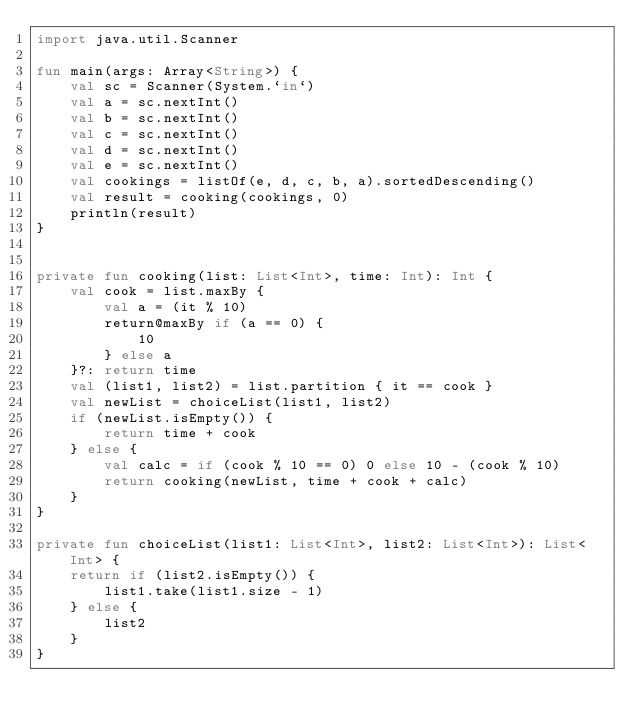Convert code to text. <code><loc_0><loc_0><loc_500><loc_500><_Kotlin_>import java.util.Scanner

fun main(args: Array<String>) {
    val sc = Scanner(System.`in`)
    val a = sc.nextInt()
    val b = sc.nextInt()
    val c = sc.nextInt()
    val d = sc.nextInt()
    val e = sc.nextInt()
    val cookings = listOf(e, d, c, b, a).sortedDescending()
    val result = cooking(cookings, 0)
    println(result)
}


private fun cooking(list: List<Int>, time: Int): Int {
    val cook = list.maxBy {
        val a = (it % 10)
        return@maxBy if (a == 0) {
            10
        } else a
    }?: return time
    val (list1, list2) = list.partition { it == cook }
    val newList = choiceList(list1, list2)
    if (newList.isEmpty()) {
        return time + cook
    } else {
        val calc = if (cook % 10 == 0) 0 else 10 - (cook % 10)
        return cooking(newList, time + cook + calc)
    }
}

private fun choiceList(list1: List<Int>, list2: List<Int>): List<Int> {
    return if (list2.isEmpty()) {
        list1.take(list1.size - 1)
    } else {
        list2
    }
}</code> 